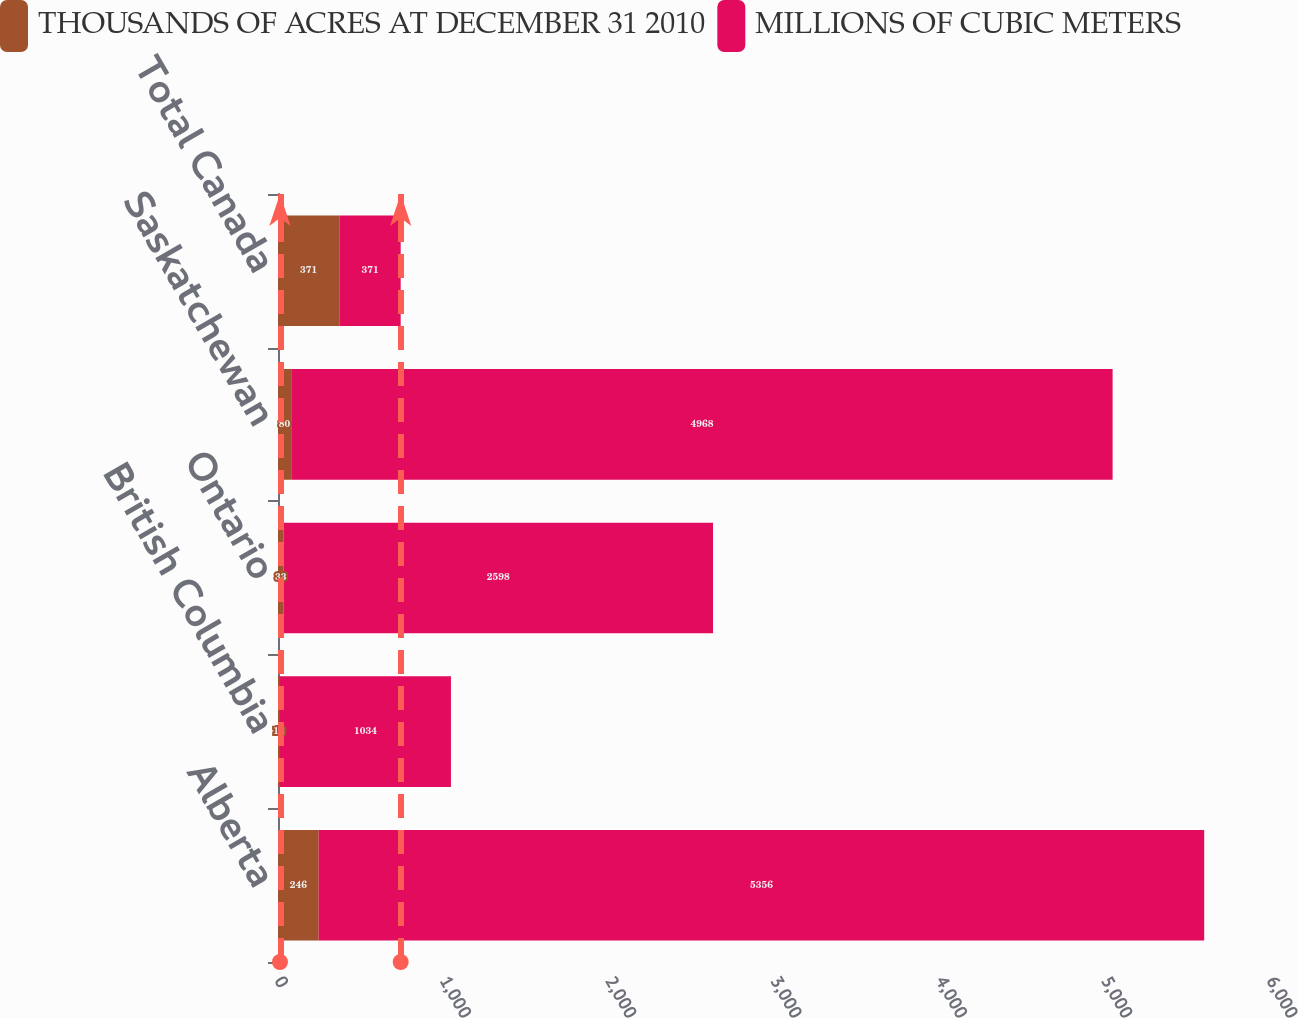Convert chart. <chart><loc_0><loc_0><loc_500><loc_500><stacked_bar_chart><ecel><fcel>Alberta<fcel>British Columbia<fcel>Ontario<fcel>Saskatchewan<fcel>Total Canada<nl><fcel>THOUSANDS OF ACRES AT DECEMBER 31 2010<fcel>246<fcel>12<fcel>33<fcel>80<fcel>371<nl><fcel>MILLIONS OF CUBIC METERS<fcel>5356<fcel>1034<fcel>2598<fcel>4968<fcel>371<nl></chart> 